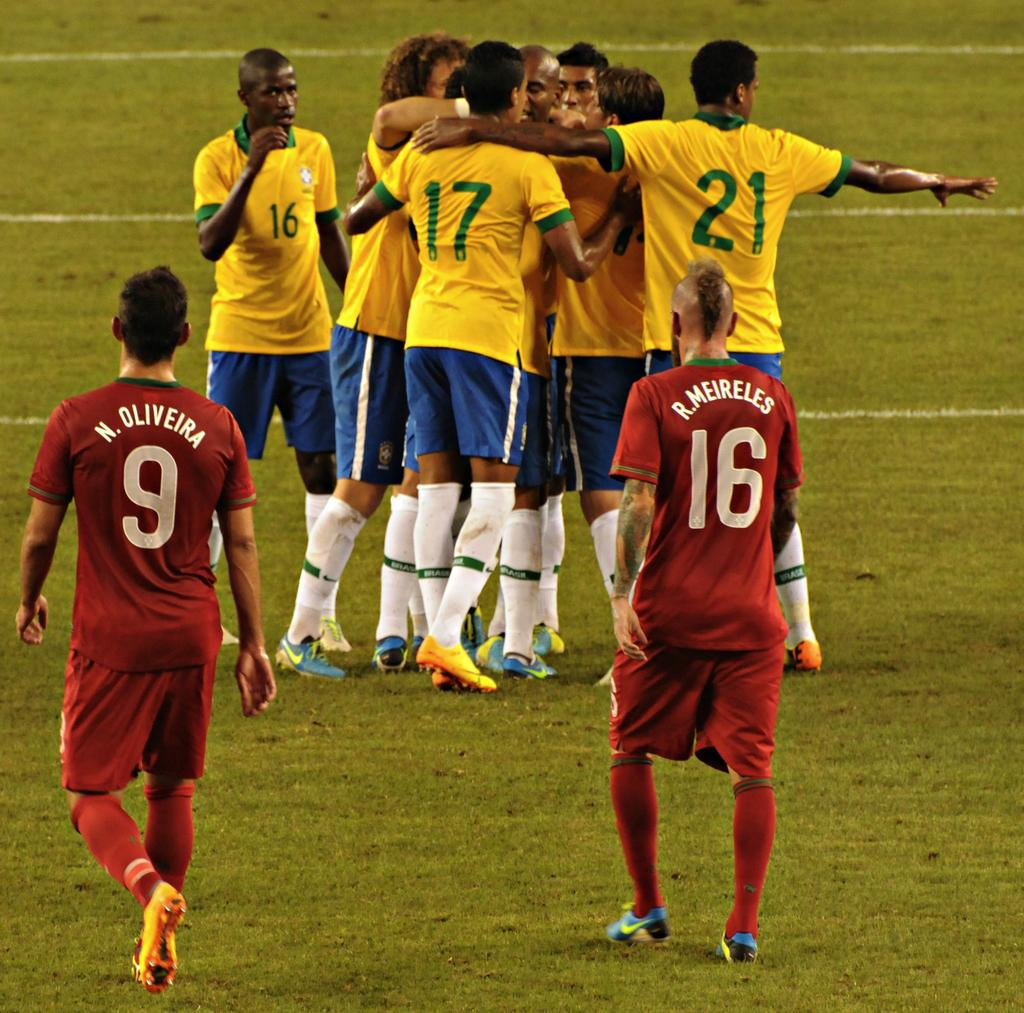<image>
Give a short and clear explanation of the subsequent image. Players number 9 and 16 walk towards their opponents on the field. 